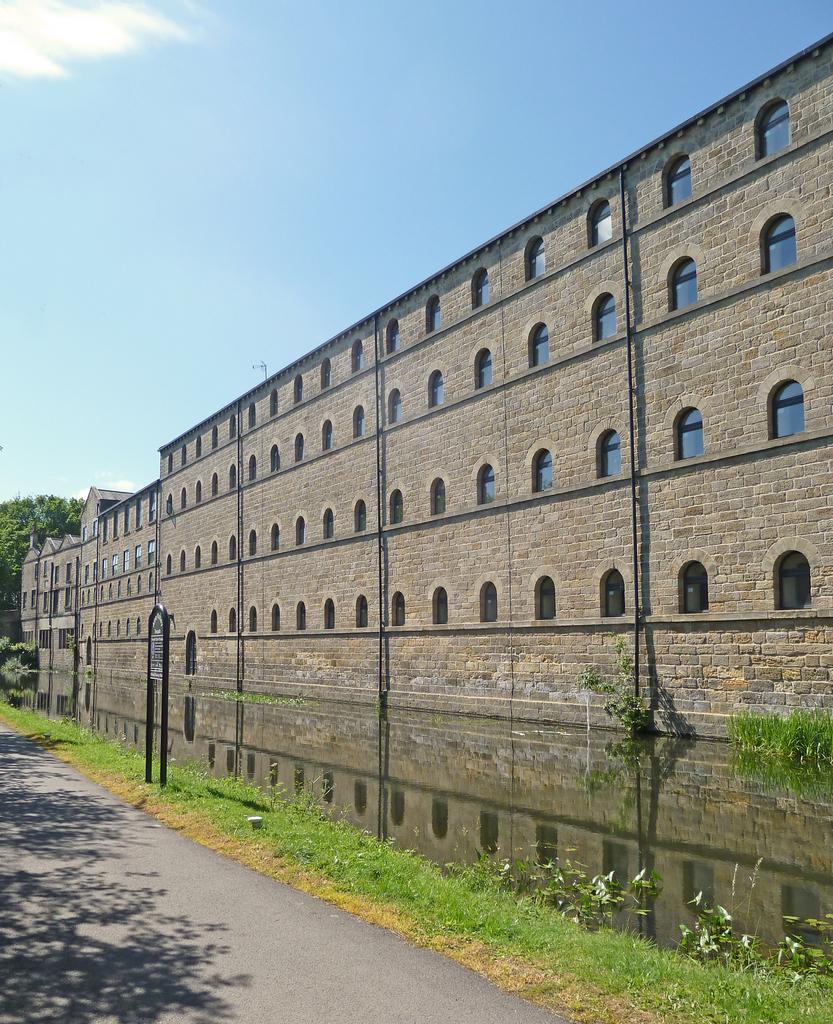Describe this image in one or two sentences. In this picture we can see the road, name board, water, grass, plants, buildings with windows, trees and in the background we can see the sky. 